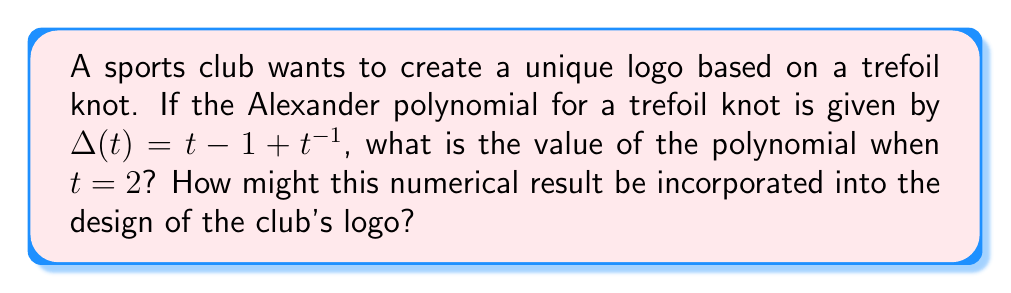Can you answer this question? To solve this problem, we'll follow these steps:

1) We're given the Alexander polynomial for a trefoil knot:
   $$\Delta(t) = t - 1 + t^{-1}$$

2) We need to evaluate this polynomial at $t = 2$. Let's substitute $t = 2$ into the equation:
   $$\Delta(2) = 2 - 1 + 2^{-1}$$

3) Let's calculate each term:
   - First term: $2$
   - Second term: $-1$
   - Third term: $2^{-1} = \frac{1}{2}$

4) Now we can add these terms:
   $$\Delta(2) = 2 - 1 + \frac{1}{2} = 1 + \frac{1}{2} = \frac{3}{2}$$

5) To incorporate this into a logo design, the club could:
   - Use the fraction 3/2 or the decimal 1.5 as part of the logo
   - Create a trefoil knot shape with 3 loops on top and 2 loops on the bottom
   - Use the number 3 in one color and 2 in another within the logo design
   - Incorporate 3 major design elements and 2 minor elements in the logo

This approach combines the mathematical concept of knot polynomials with practical logo design, making it relevant for a sports management student who leads a club.
Answer: $\frac{3}{2}$ or 1.5 